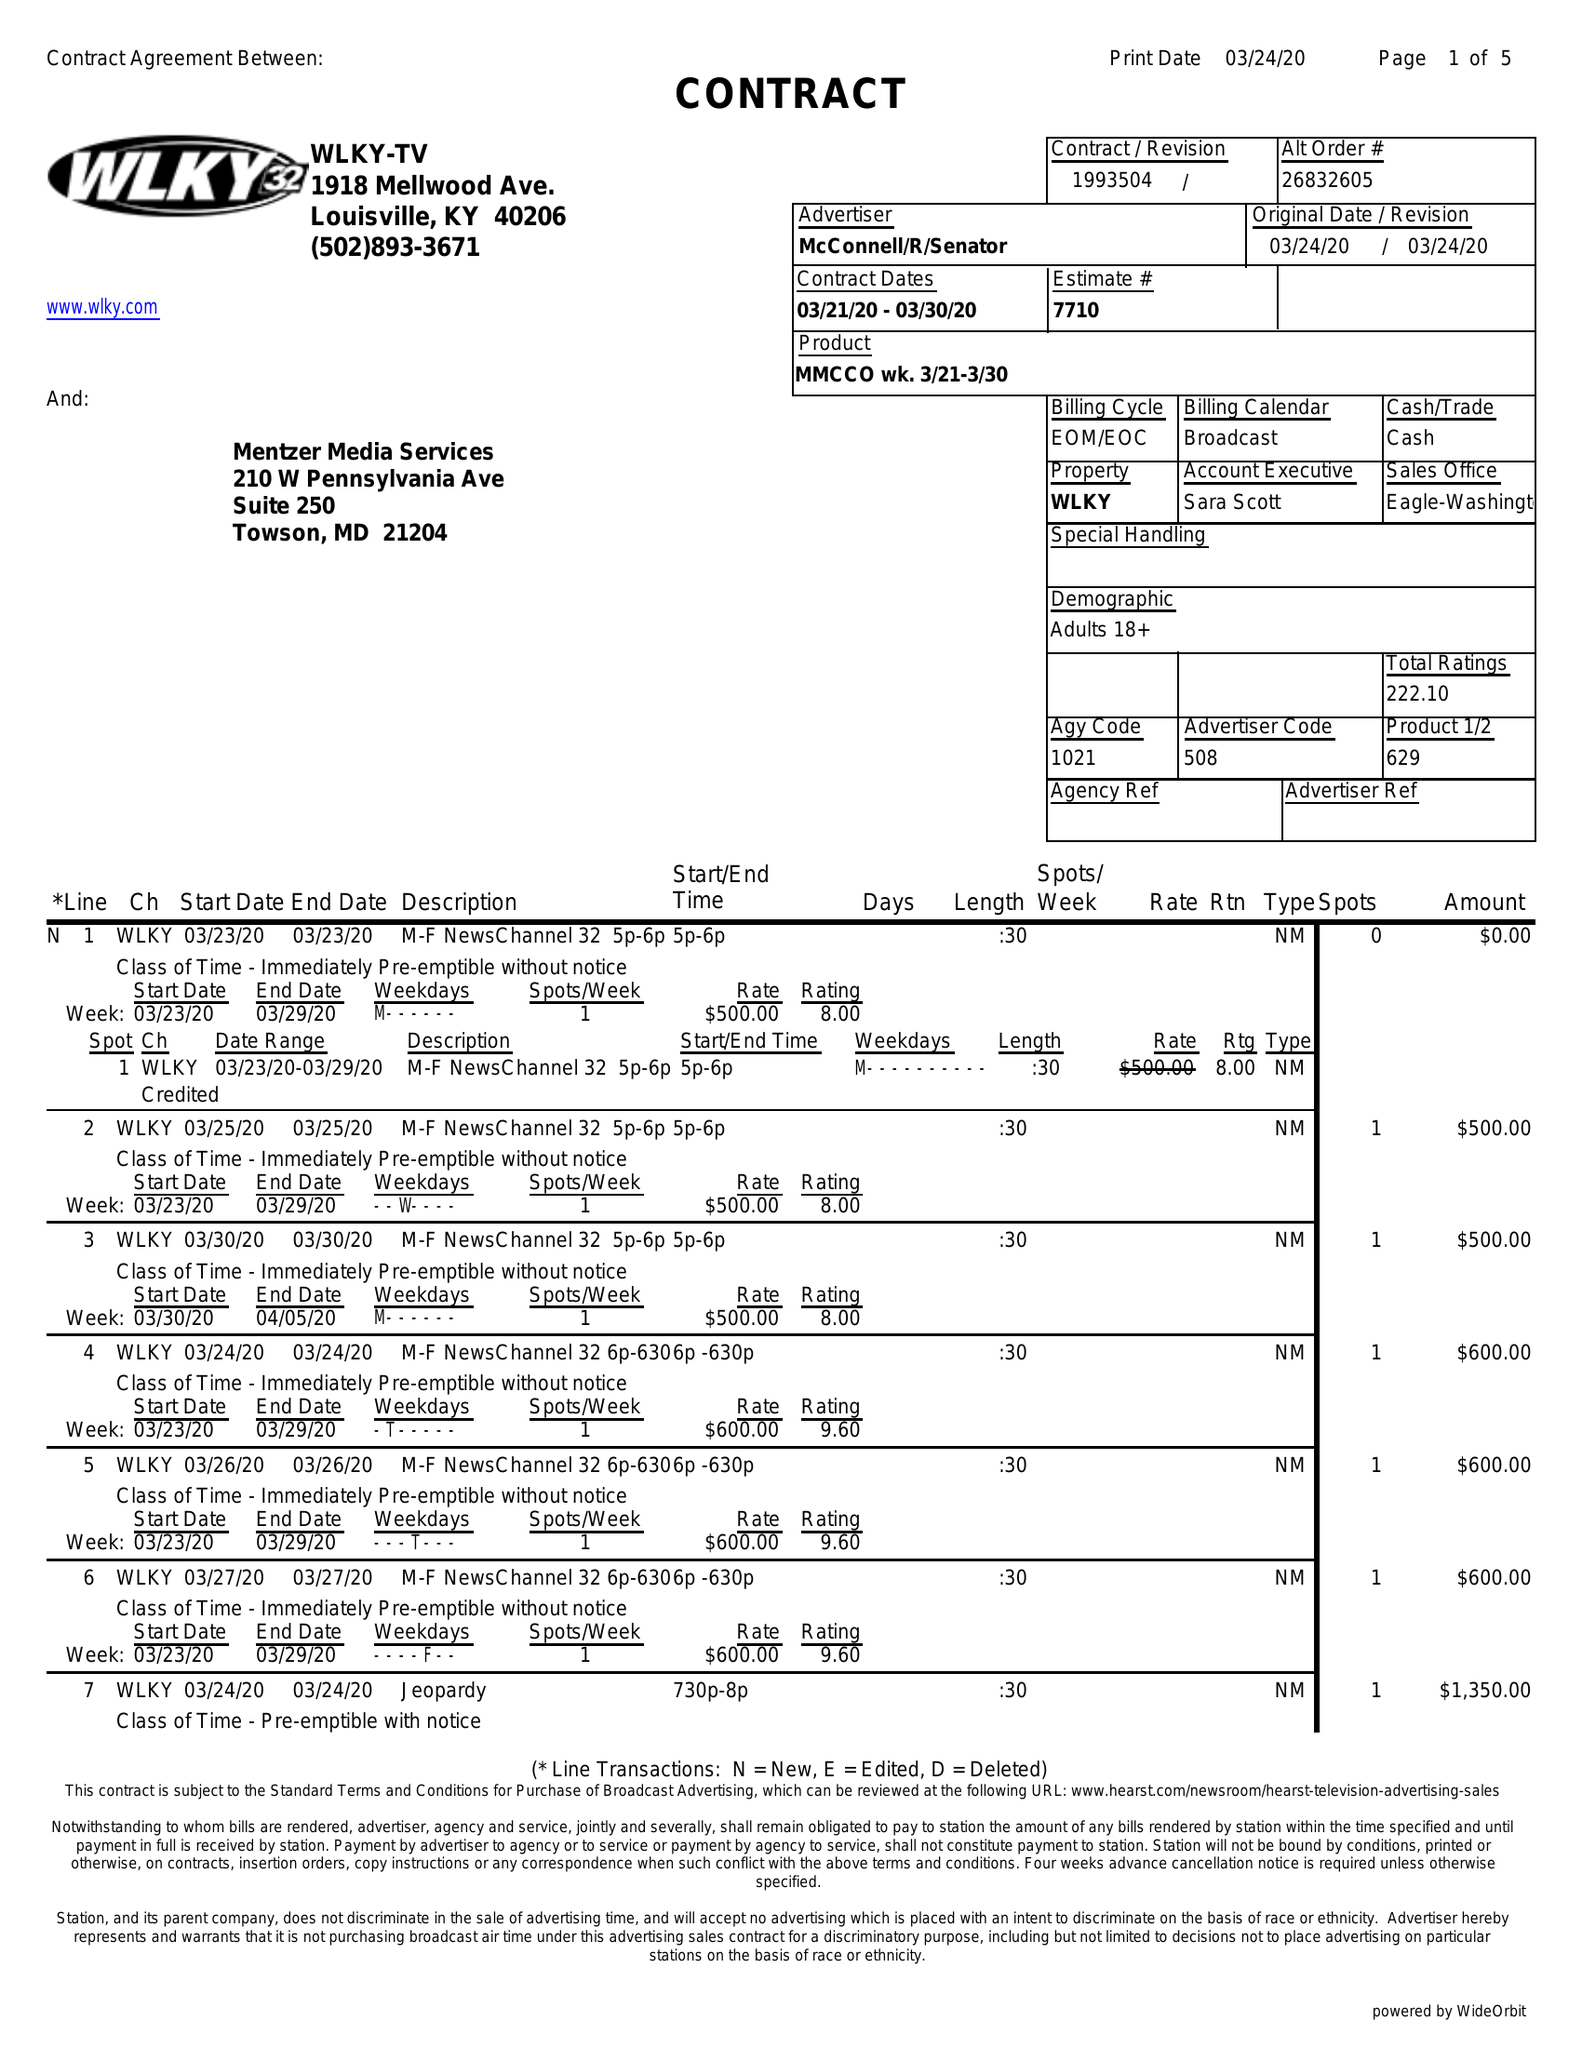What is the value for the advertiser?
Answer the question using a single word or phrase. MCCONNELL/R/SENATOR 